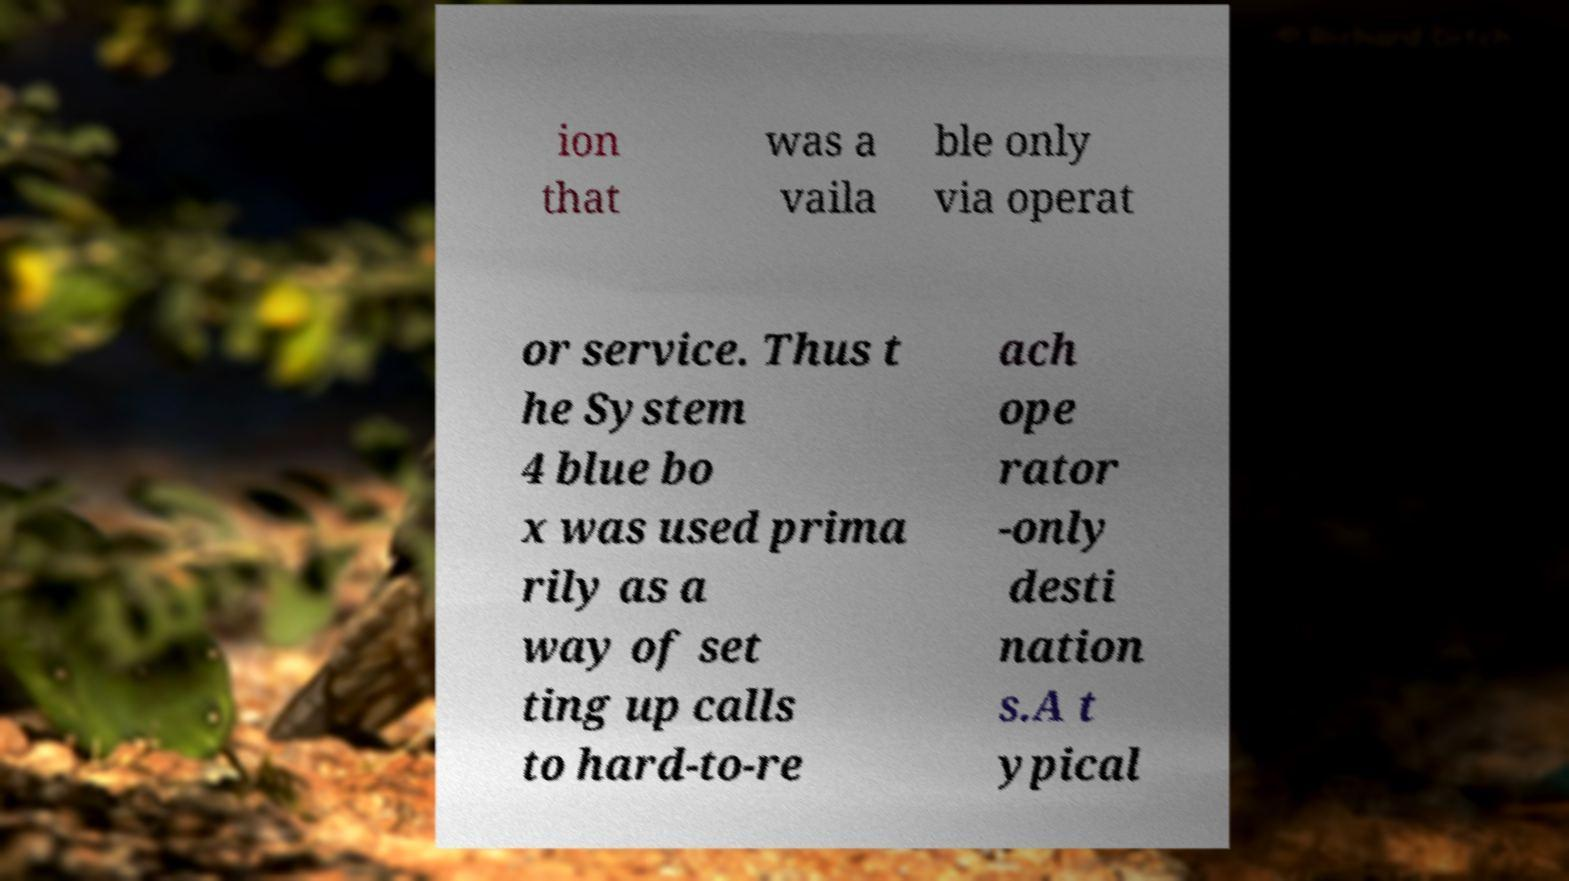Could you assist in decoding the text presented in this image and type it out clearly? ion that was a vaila ble only via operat or service. Thus t he System 4 blue bo x was used prima rily as a way of set ting up calls to hard-to-re ach ope rator -only desti nation s.A t ypical 